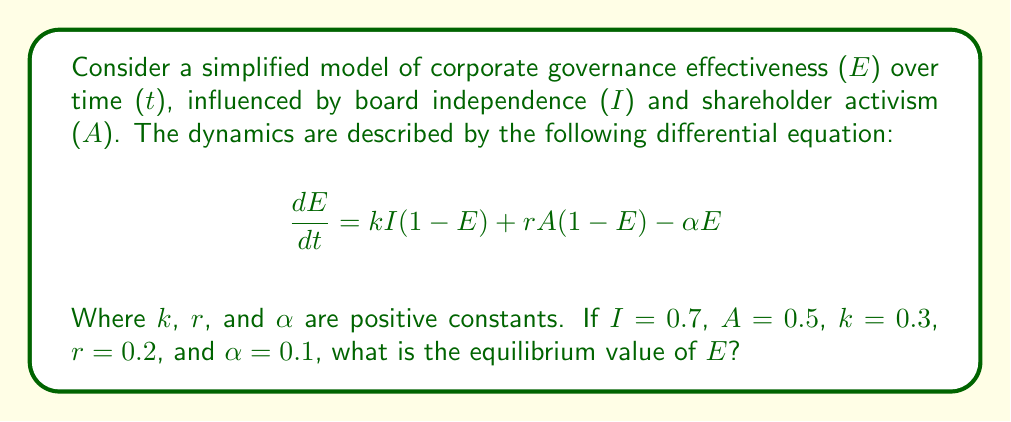Could you help me with this problem? To find the equilibrium value of E, we need to set the rate of change (dE/dt) to zero and solve for E:

1) Set the equation equal to zero:
   $$0 = kI(1-E) + rA(1-E) - \alpha E$$

2) Substitute the given values:
   $$0 = 0.3(0.7)(1-E) + 0.2(0.5)(1-E) - 0.1E$$

3) Simplify:
   $$0 = 0.21(1-E) + 0.1(1-E) - 0.1E$$
   $$0 = 0.21 - 0.21E + 0.1 - 0.1E - 0.1E$$
   $$0 = 0.31 - 0.41E$$

4) Solve for E:
   $$0.41E = 0.31$$
   $$E = \frac{0.31}{0.41} \approx 0.7561$$

Therefore, the equilibrium value of E is approximately 0.7561 or 75.61%.
Answer: 0.7561 